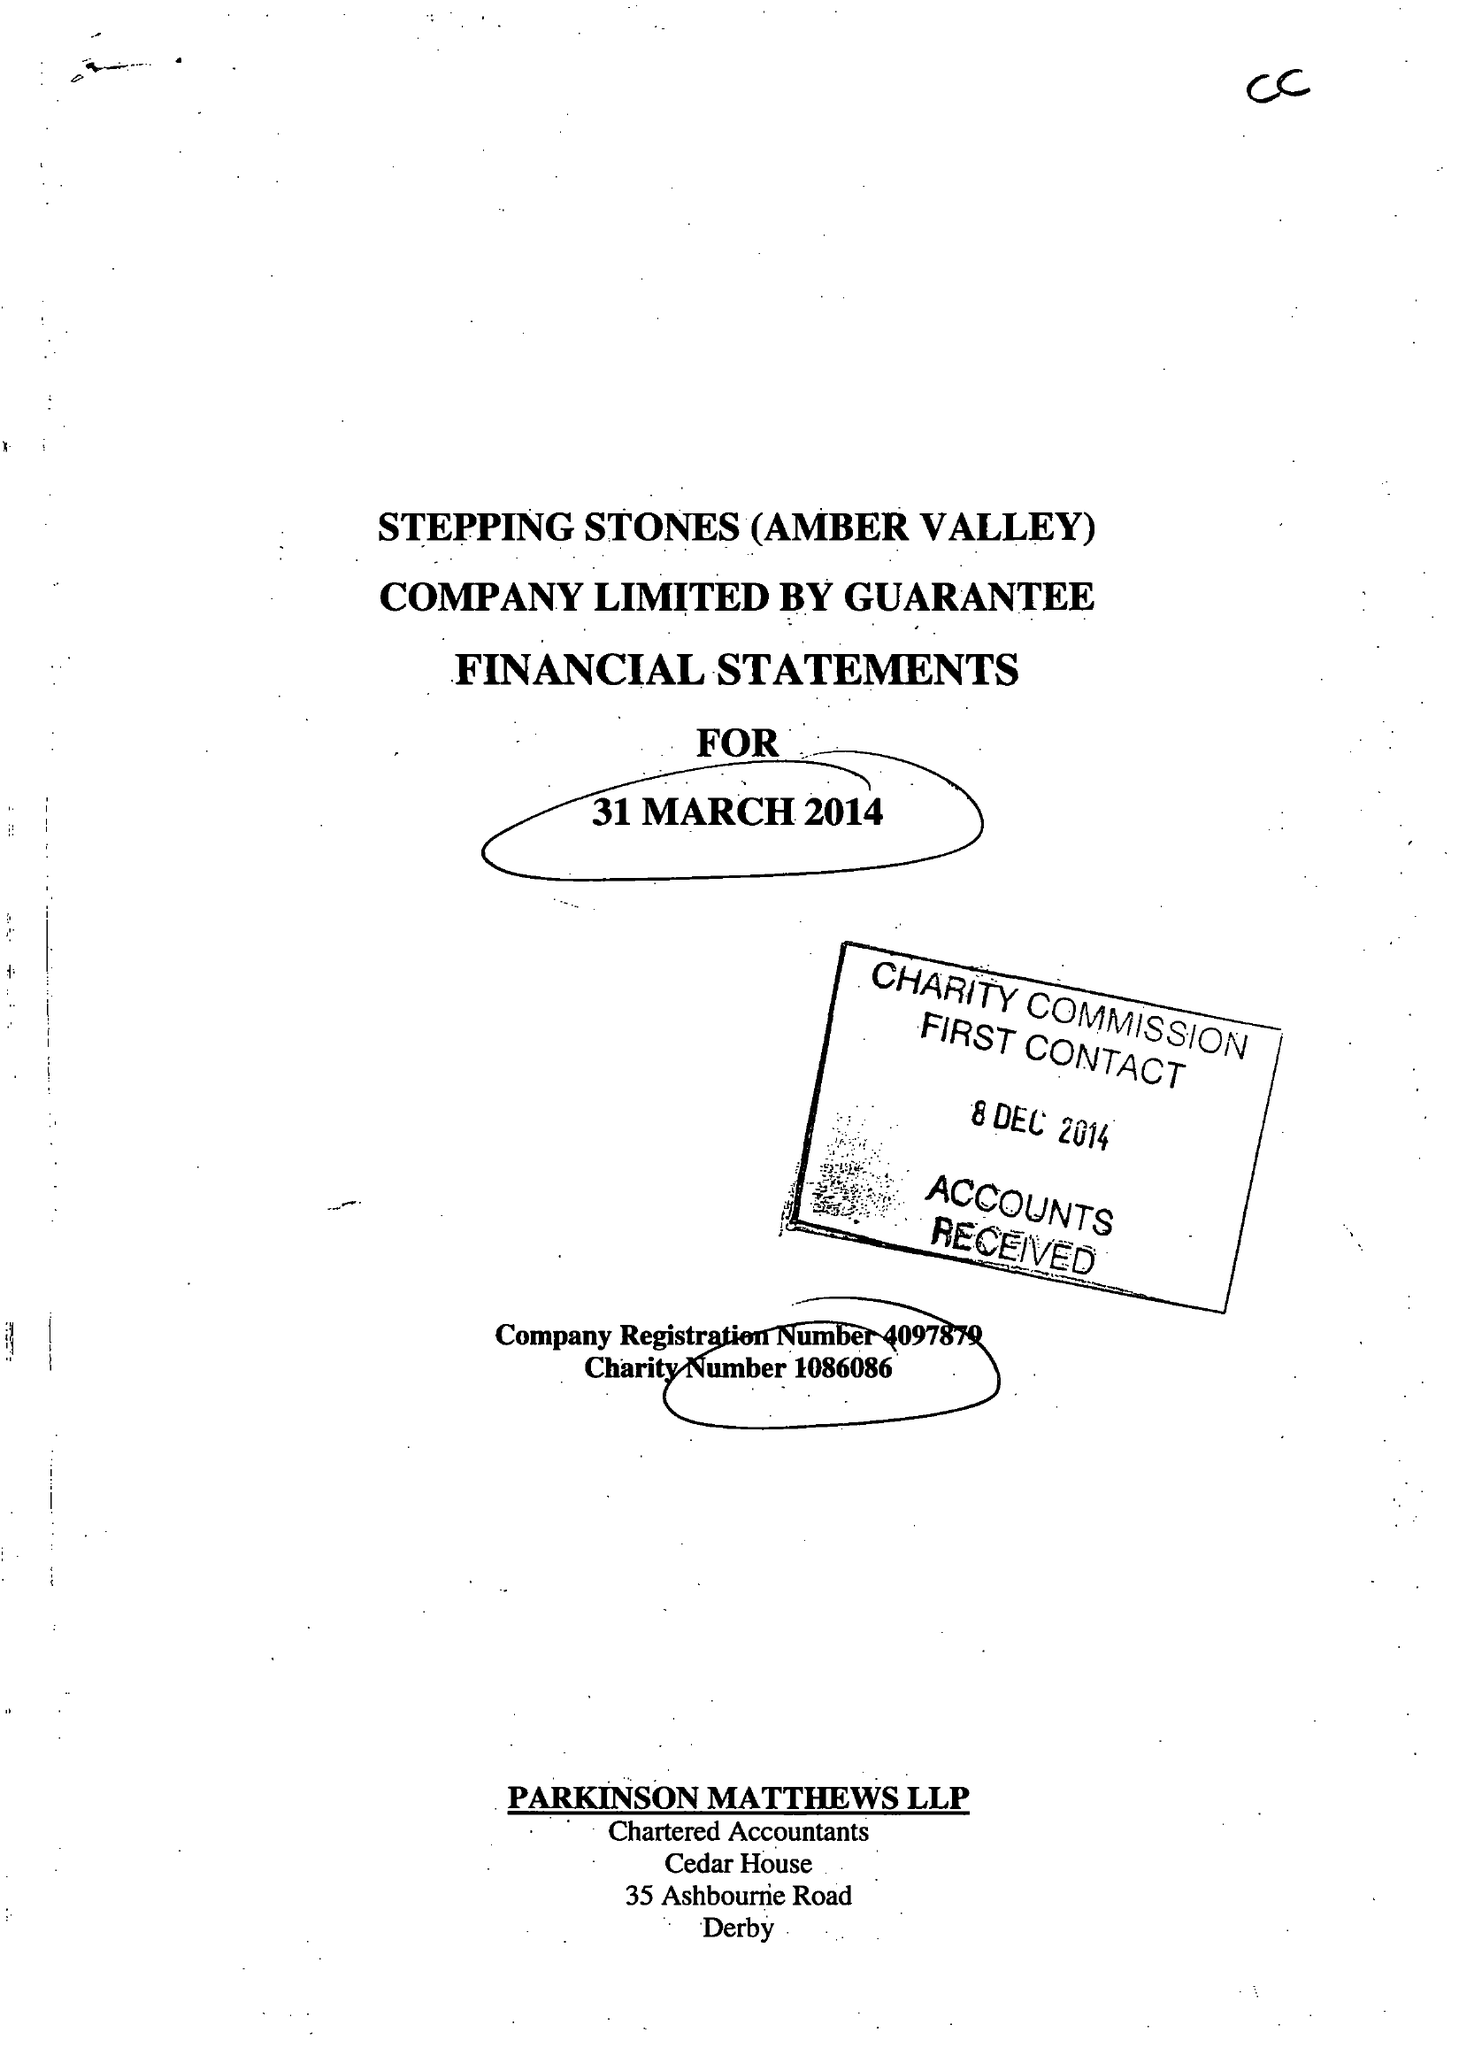What is the value for the address__post_town?
Answer the question using a single word or phrase. HEANOR 